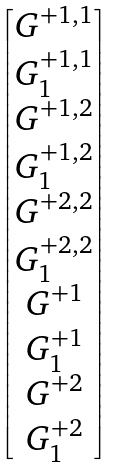<formula> <loc_0><loc_0><loc_500><loc_500>\begin{bmatrix} G ^ { + 1 , 1 } \\ G ^ { + 1 , 1 } _ { 1 } \\ G ^ { + 1 , 2 } \\ G ^ { + 1 , 2 } _ { 1 } \\ G ^ { + 2 , 2 } \\ G ^ { + 2 , 2 } _ { 1 } \\ G ^ { + 1 } \\ G ^ { + 1 } _ { 1 } \\ G ^ { + 2 } \\ G ^ { + 2 } _ { 1 } \end{bmatrix}</formula> 